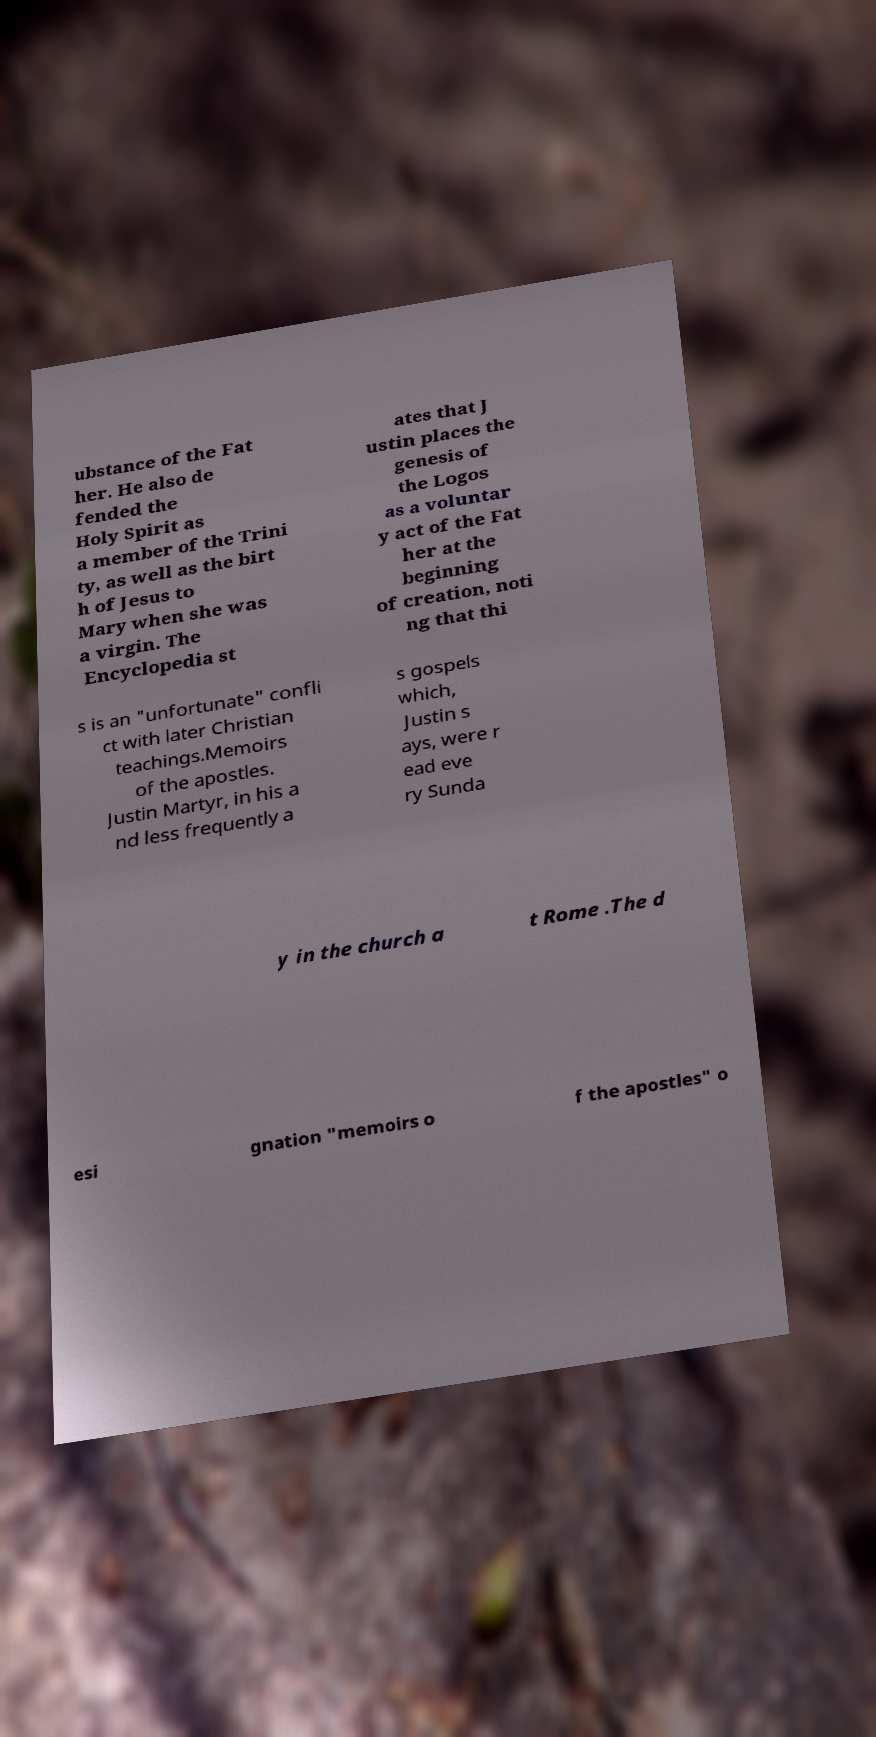Can you read and provide the text displayed in the image?This photo seems to have some interesting text. Can you extract and type it out for me? ubstance of the Fat her. He also de fended the Holy Spirit as a member of the Trini ty, as well as the birt h of Jesus to Mary when she was a virgin. The Encyclopedia st ates that J ustin places the genesis of the Logos as a voluntar y act of the Fat her at the beginning of creation, noti ng that thi s is an "unfortunate" confli ct with later Christian teachings.Memoirs of the apostles. Justin Martyr, in his a nd less frequently a s gospels which, Justin s ays, were r ead eve ry Sunda y in the church a t Rome .The d esi gnation "memoirs o f the apostles" o 